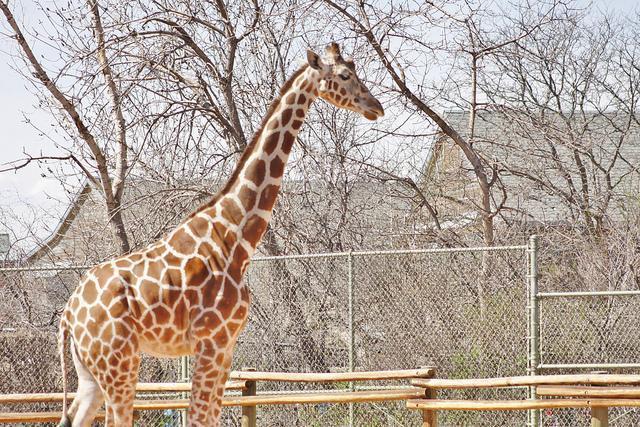How many different types of fences are there?
Give a very brief answer. 2. How many giraffes are in the photo?
Give a very brief answer. 1. 